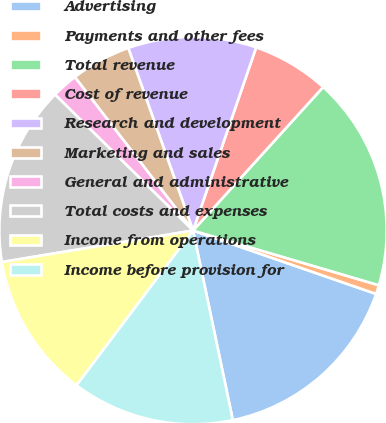Convert chart. <chart><loc_0><loc_0><loc_500><loc_500><pie_chart><fcel>Advertising<fcel>Payments and other fees<fcel>Total revenue<fcel>Cost of revenue<fcel>Research and development<fcel>Marketing and sales<fcel>General and administrative<fcel>Total costs and expenses<fcel>Income from operations<fcel>Income before provision for<nl><fcel>16.4%<fcel>0.75%<fcel>17.83%<fcel>6.44%<fcel>10.71%<fcel>5.02%<fcel>2.17%<fcel>14.98%<fcel>12.13%<fcel>13.56%<nl></chart> 